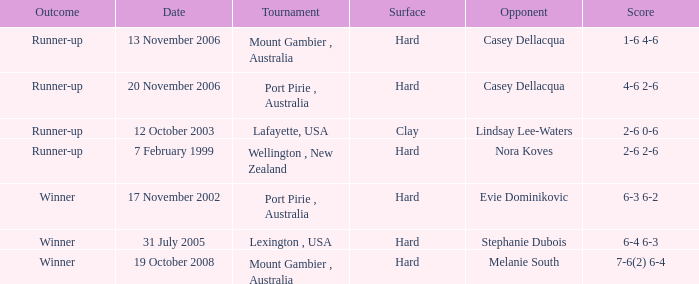Could you help me parse every detail presented in this table? {'header': ['Outcome', 'Date', 'Tournament', 'Surface', 'Opponent', 'Score'], 'rows': [['Runner-up', '13 November 2006', 'Mount Gambier , Australia', 'Hard', 'Casey Dellacqua', '1-6 4-6'], ['Runner-up', '20 November 2006', 'Port Pirie , Australia', 'Hard', 'Casey Dellacqua', '4-6 2-6'], ['Runner-up', '12 October 2003', 'Lafayette, USA', 'Clay', 'Lindsay Lee-Waters', '2-6 0-6'], ['Runner-up', '7 February 1999', 'Wellington , New Zealand', 'Hard', 'Nora Koves', '2-6 2-6'], ['Winner', '17 November 2002', 'Port Pirie , Australia', 'Hard', 'Evie Dominikovic', '6-3 6-2'], ['Winner', '31 July 2005', 'Lexington , USA', 'Hard', 'Stephanie Dubois', '6-4 6-3'], ['Winner', '19 October 2008', 'Mount Gambier , Australia', 'Hard', 'Melanie South', '7-6(2) 6-4']]} What happens to a player who goes up against lindsay lee-waters? Runner-up. 